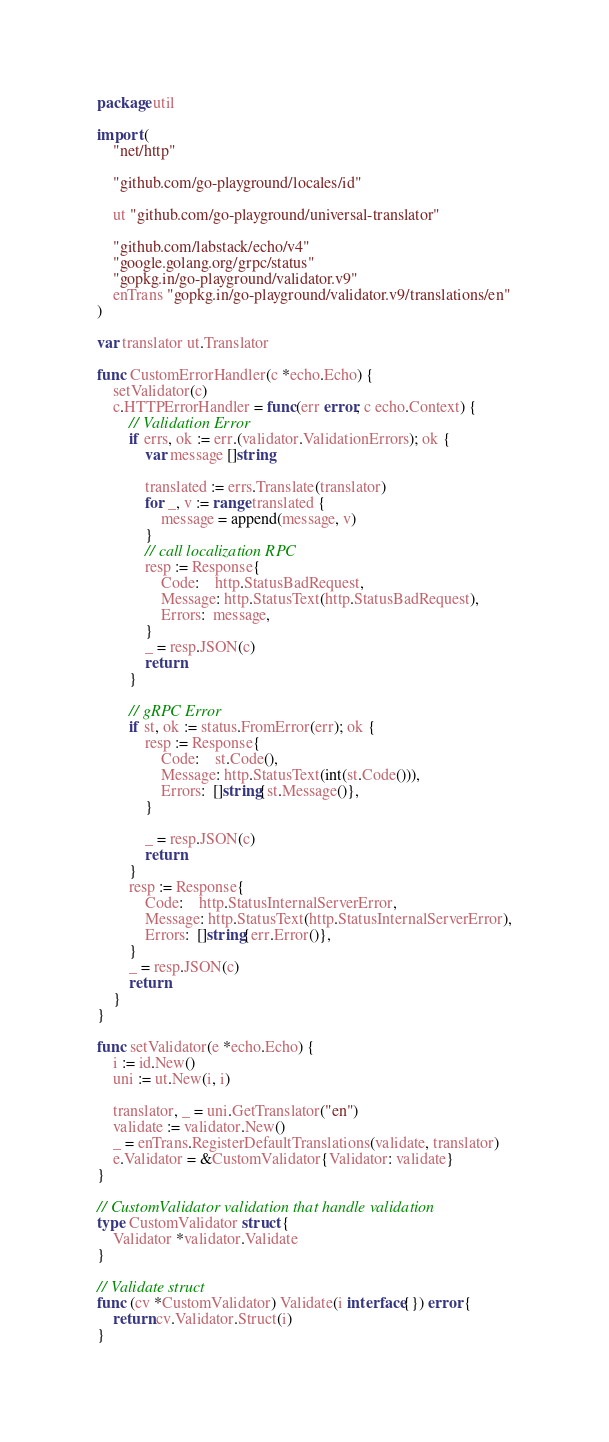<code> <loc_0><loc_0><loc_500><loc_500><_Go_>package util

import (
	"net/http"

	"github.com/go-playground/locales/id"

	ut "github.com/go-playground/universal-translator"

	"github.com/labstack/echo/v4"
	"google.golang.org/grpc/status"
	"gopkg.in/go-playground/validator.v9"
	enTrans "gopkg.in/go-playground/validator.v9/translations/en"
)

var translator ut.Translator

func CustomErrorHandler(c *echo.Echo) {
	setValidator(c)
	c.HTTPErrorHandler = func(err error, c echo.Context) {
		// Validation Error
		if errs, ok := err.(validator.ValidationErrors); ok {
			var message []string

			translated := errs.Translate(translator)
			for _, v := range translated {
				message = append(message, v)
			}
			// call localization RPC
			resp := Response{
				Code:    http.StatusBadRequest,
				Message: http.StatusText(http.StatusBadRequest),
				Errors:  message,
			}
			_ = resp.JSON(c)
			return
		}

		// gRPC Error
		if st, ok := status.FromError(err); ok {
			resp := Response{
				Code:    st.Code(),
				Message: http.StatusText(int(st.Code())),
				Errors:  []string{st.Message()},
			}

			_ = resp.JSON(c)
			return
		}
		resp := Response{
			Code:    http.StatusInternalServerError,
			Message: http.StatusText(http.StatusInternalServerError),
			Errors:  []string{err.Error()},
		}
		_ = resp.JSON(c)
		return
	}
}

func setValidator(e *echo.Echo) {
	i := id.New()
	uni := ut.New(i, i)

	translator, _ = uni.GetTranslator("en")
	validate := validator.New()
	_ = enTrans.RegisterDefaultTranslations(validate, translator)
	e.Validator = &CustomValidator{Validator: validate}
}

// CustomValidator validation that handle validation
type CustomValidator struct {
	Validator *validator.Validate
}

// Validate struct
func (cv *CustomValidator) Validate(i interface{}) error {
	return cv.Validator.Struct(i)
}
</code> 